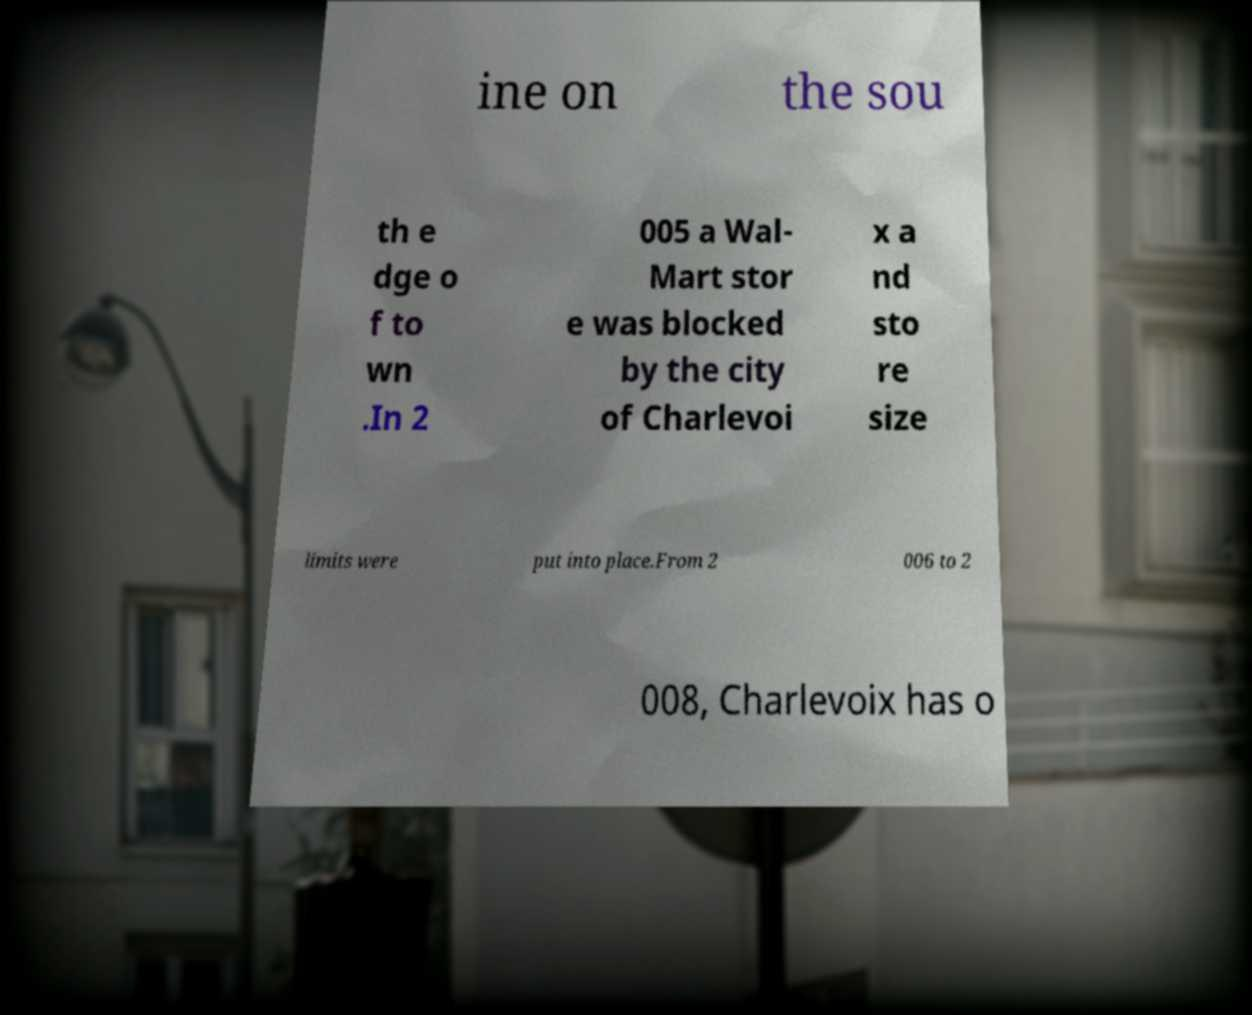Please identify and transcribe the text found in this image. ine on the sou th e dge o f to wn .In 2 005 a Wal- Mart stor e was blocked by the city of Charlevoi x a nd sto re size limits were put into place.From 2 006 to 2 008, Charlevoix has o 